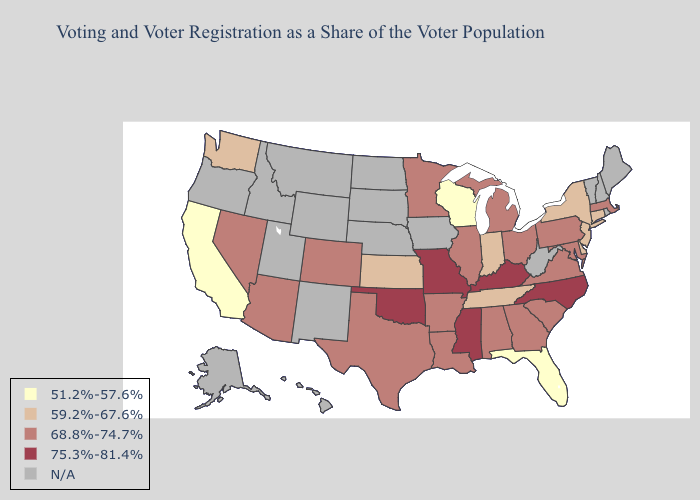Name the states that have a value in the range 68.8%-74.7%?
Quick response, please. Alabama, Arizona, Arkansas, Colorado, Georgia, Illinois, Louisiana, Maryland, Massachusetts, Michigan, Minnesota, Nevada, Ohio, Pennsylvania, South Carolina, Texas, Virginia. Among the states that border Tennessee , does Alabama have the highest value?
Write a very short answer. No. What is the highest value in the West ?
Short answer required. 68.8%-74.7%. Name the states that have a value in the range 59.2%-67.6%?
Quick response, please. Connecticut, Delaware, Indiana, Kansas, New Jersey, New York, Tennessee, Washington. Does the map have missing data?
Be succinct. Yes. What is the value of North Dakota?
Quick response, please. N/A. Does the first symbol in the legend represent the smallest category?
Be succinct. Yes. What is the value of New Mexico?
Be succinct. N/A. What is the value of Illinois?
Answer briefly. 68.8%-74.7%. Does the first symbol in the legend represent the smallest category?
Short answer required. Yes. Name the states that have a value in the range N/A?
Concise answer only. Alaska, Hawaii, Idaho, Iowa, Maine, Montana, Nebraska, New Hampshire, New Mexico, North Dakota, Oregon, Rhode Island, South Dakota, Utah, Vermont, West Virginia, Wyoming. What is the lowest value in states that border Kansas?
Short answer required. 68.8%-74.7%. What is the value of Florida?
Quick response, please. 51.2%-57.6%. 